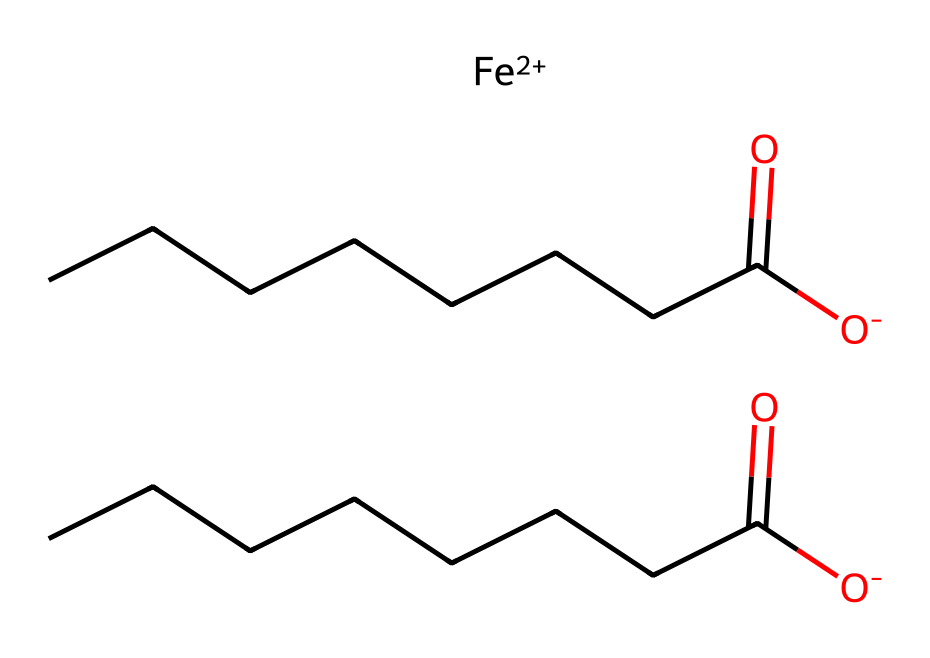What is the central metal in this compound? The central metal in the provided SMILES representation is identified as iron, which is indicated by the [Fe+2] notation.
Answer: iron How many carbon atoms are in this chemical? By examining the carbon chain in the structure, two carboxylate groups (each with one carbon) and a linear carbon chain of seven additional carbons can be counted, totaling eight carbon atoms.
Answer: eight What type of chemical functional groups are present? The presence of the carboxylate groups is recognized by the -COO- structure (from the [O-]C(=O) notation), which indicates two carboxylate functional groups in this compound.
Answer: carboxylate What is the oxidation state of iron in this compound? The oxidation state of iron is shown in the SMILES representation as +2, indicated directly by the [Fe+2] placement, signifying that iron has lost two electrons.
Answer: +2 How many oxygen atoms are present in the compound? The two carboxylate groups each contribute two oxygen atoms (totaling four), and there are no other oxygen atoms present, leading to a total of four oxygen atoms.
Answer: four Is this compound eco-friendly based on its composition? The use of organometallic compounds, particularly with straightforward carbon and carboxylate functionalities, suggests a more eco-friendly nature, as they often have less toxicity and are biodegradable compared to other metal-organic compounds.
Answer: yes What type of bonding exists between the metal and the carbon chains? The bonding between the iron and the carbon chains occurs through coordinate covalent bonding, where the metal ion coordinates with the electron pair from the carboxylate functional groups.
Answer: coordinate covalent 